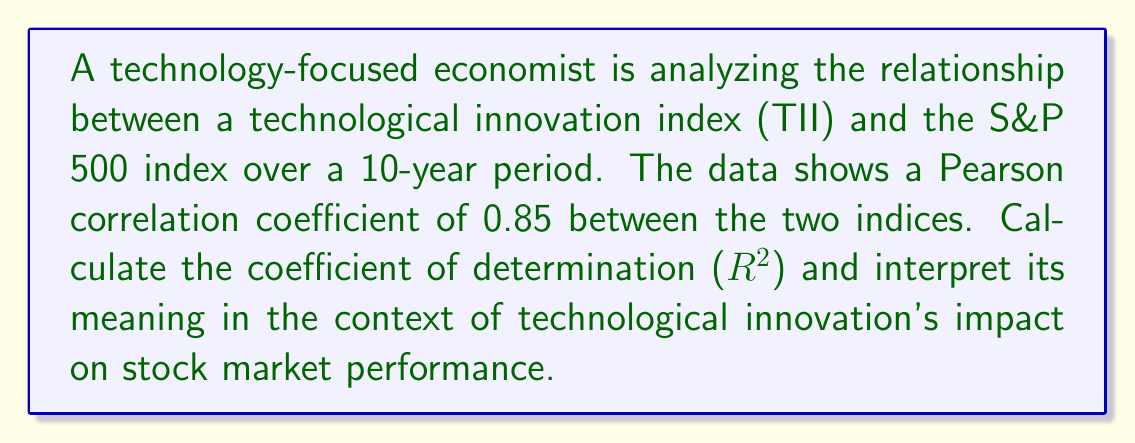Solve this math problem. To solve this problem, we'll follow these steps:

1. Understand the given information:
   - We have a Pearson correlation coefficient (r) of 0.85
   - We need to calculate the coefficient of determination ($R^2$)

2. Calculate $R^2$:
   The coefficient of determination is the square of the Pearson correlation coefficient.
   
   $R^2 = r^2$
   
   $R^2 = (0.85)^2 = 0.7225$

3. Interpret the result:
   The $R^2$ value of 0.7225 means that approximately 72.25% of the variance in the S&P 500 index can be explained by changes in the Technological Innovation Index.

   In the context of technological innovation's impact on stock market performance:
   - This strong positive relationship suggests that technological innovations have a significant influence on stock market performance.
   - About 72.25% of the movements in the S&P 500 can be attributed to changes in technological innovation, as measured by the TII.
   - The remaining 27.75% of the variance in the S&P 500 is due to other factors not captured by the TII.

   This high $R^2$ value indicates that technological innovation is a crucial factor in explaining stock market performance, which is valuable information for an economist studying the impact of technology on financial markets.
Answer: $R^2 = 0.7225$, indicating 72.25% of S&P 500 variance is explained by the Technological Innovation Index. 